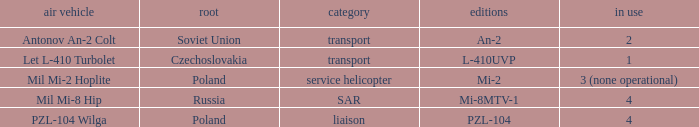Tell me the versions for czechoslovakia? L-410UVP. Would you be able to parse every entry in this table? {'header': ['air vehicle', 'root', 'category', 'editions', 'in use'], 'rows': [['Antonov An-2 Colt', 'Soviet Union', 'transport', 'An-2', '2'], ['Let L-410 Turbolet', 'Czechoslovakia', 'transport', 'L-410UVP', '1'], ['Mil Mi-2 Hoplite', 'Poland', 'service helicopter', 'Mi-2', '3 (none operational)'], ['Mil Mi-8 Hip', 'Russia', 'SAR', 'Mi-8MTV-1', '4'], ['PZL-104 Wilga', 'Poland', 'liaison', 'PZL-104', '4']]} 